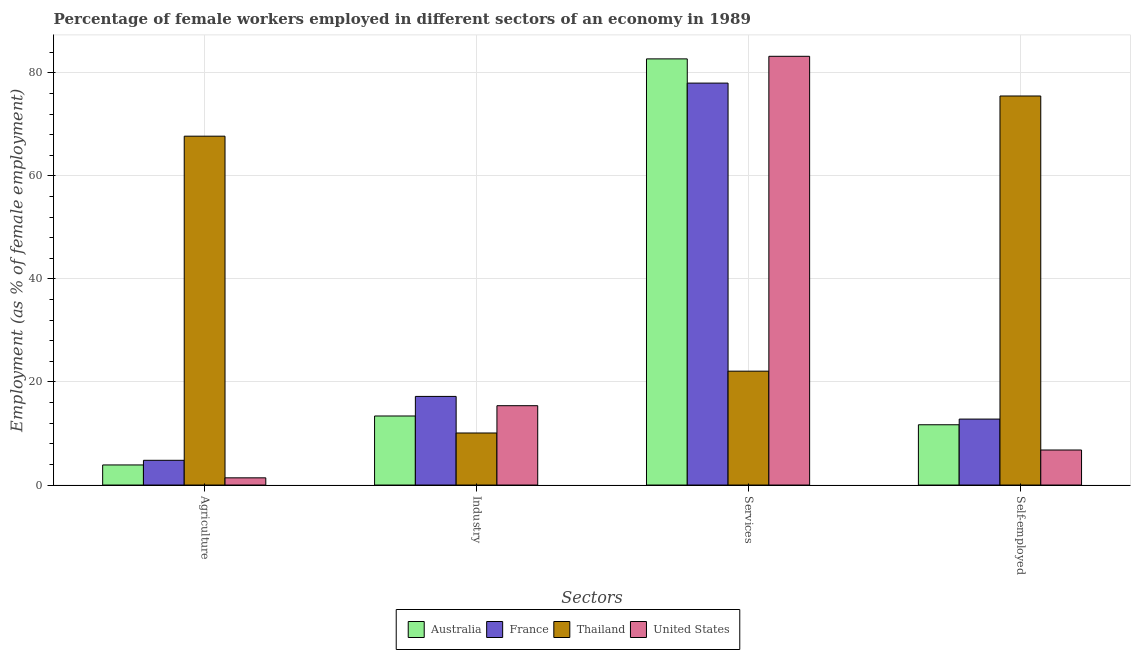How many groups of bars are there?
Provide a short and direct response. 4. How many bars are there on the 2nd tick from the left?
Your answer should be compact. 4. What is the label of the 1st group of bars from the left?
Make the answer very short. Agriculture. What is the percentage of female workers in services in Thailand?
Your answer should be compact. 22.1. Across all countries, what is the maximum percentage of self employed female workers?
Your response must be concise. 75.5. Across all countries, what is the minimum percentage of female workers in agriculture?
Give a very brief answer. 1.4. In which country was the percentage of female workers in agriculture maximum?
Ensure brevity in your answer.  Thailand. In which country was the percentage of female workers in services minimum?
Provide a short and direct response. Thailand. What is the total percentage of female workers in agriculture in the graph?
Provide a short and direct response. 77.8. What is the difference between the percentage of female workers in services in Thailand and that in United States?
Provide a short and direct response. -61.1. What is the difference between the percentage of female workers in services in France and the percentage of self employed female workers in Thailand?
Your response must be concise. 2.5. What is the average percentage of female workers in agriculture per country?
Keep it short and to the point. 19.45. What is the difference between the percentage of self employed female workers and percentage of female workers in services in United States?
Your response must be concise. -76.4. In how many countries, is the percentage of self employed female workers greater than 12 %?
Offer a terse response. 2. What is the ratio of the percentage of female workers in agriculture in France to that in Thailand?
Give a very brief answer. 0.07. Is the difference between the percentage of female workers in agriculture in United States and Thailand greater than the difference between the percentage of female workers in services in United States and Thailand?
Make the answer very short. No. What is the difference between the highest and the second highest percentage of female workers in services?
Your answer should be very brief. 0.5. What is the difference between the highest and the lowest percentage of female workers in industry?
Offer a very short reply. 7.1. In how many countries, is the percentage of female workers in industry greater than the average percentage of female workers in industry taken over all countries?
Offer a very short reply. 2. What does the 3rd bar from the right in Agriculture represents?
Offer a terse response. France. How many bars are there?
Provide a short and direct response. 16. Are the values on the major ticks of Y-axis written in scientific E-notation?
Your answer should be compact. No. Does the graph contain any zero values?
Provide a short and direct response. No. Does the graph contain grids?
Provide a short and direct response. Yes. Where does the legend appear in the graph?
Ensure brevity in your answer.  Bottom center. What is the title of the graph?
Give a very brief answer. Percentage of female workers employed in different sectors of an economy in 1989. What is the label or title of the X-axis?
Offer a terse response. Sectors. What is the label or title of the Y-axis?
Offer a terse response. Employment (as % of female employment). What is the Employment (as % of female employment) of Australia in Agriculture?
Provide a succinct answer. 3.9. What is the Employment (as % of female employment) of France in Agriculture?
Your response must be concise. 4.8. What is the Employment (as % of female employment) of Thailand in Agriculture?
Your response must be concise. 67.7. What is the Employment (as % of female employment) in United States in Agriculture?
Provide a succinct answer. 1.4. What is the Employment (as % of female employment) of Australia in Industry?
Provide a short and direct response. 13.4. What is the Employment (as % of female employment) in France in Industry?
Your answer should be compact. 17.2. What is the Employment (as % of female employment) in Thailand in Industry?
Your response must be concise. 10.1. What is the Employment (as % of female employment) in United States in Industry?
Make the answer very short. 15.4. What is the Employment (as % of female employment) in Australia in Services?
Ensure brevity in your answer.  82.7. What is the Employment (as % of female employment) of France in Services?
Offer a terse response. 78. What is the Employment (as % of female employment) in Thailand in Services?
Provide a succinct answer. 22.1. What is the Employment (as % of female employment) in United States in Services?
Provide a short and direct response. 83.2. What is the Employment (as % of female employment) in Australia in Self-employed?
Offer a terse response. 11.7. What is the Employment (as % of female employment) in France in Self-employed?
Your answer should be compact. 12.8. What is the Employment (as % of female employment) of Thailand in Self-employed?
Keep it short and to the point. 75.5. What is the Employment (as % of female employment) in United States in Self-employed?
Provide a short and direct response. 6.8. Across all Sectors, what is the maximum Employment (as % of female employment) of Australia?
Offer a terse response. 82.7. Across all Sectors, what is the maximum Employment (as % of female employment) in France?
Your answer should be very brief. 78. Across all Sectors, what is the maximum Employment (as % of female employment) of Thailand?
Offer a terse response. 75.5. Across all Sectors, what is the maximum Employment (as % of female employment) in United States?
Make the answer very short. 83.2. Across all Sectors, what is the minimum Employment (as % of female employment) of Australia?
Offer a terse response. 3.9. Across all Sectors, what is the minimum Employment (as % of female employment) of France?
Your response must be concise. 4.8. Across all Sectors, what is the minimum Employment (as % of female employment) in Thailand?
Keep it short and to the point. 10.1. Across all Sectors, what is the minimum Employment (as % of female employment) of United States?
Your answer should be very brief. 1.4. What is the total Employment (as % of female employment) in Australia in the graph?
Offer a terse response. 111.7. What is the total Employment (as % of female employment) in France in the graph?
Your response must be concise. 112.8. What is the total Employment (as % of female employment) in Thailand in the graph?
Offer a terse response. 175.4. What is the total Employment (as % of female employment) in United States in the graph?
Your answer should be compact. 106.8. What is the difference between the Employment (as % of female employment) of Australia in Agriculture and that in Industry?
Offer a very short reply. -9.5. What is the difference between the Employment (as % of female employment) in Thailand in Agriculture and that in Industry?
Give a very brief answer. 57.6. What is the difference between the Employment (as % of female employment) in United States in Agriculture and that in Industry?
Provide a short and direct response. -14. What is the difference between the Employment (as % of female employment) of Australia in Agriculture and that in Services?
Make the answer very short. -78.8. What is the difference between the Employment (as % of female employment) in France in Agriculture and that in Services?
Offer a terse response. -73.2. What is the difference between the Employment (as % of female employment) of Thailand in Agriculture and that in Services?
Give a very brief answer. 45.6. What is the difference between the Employment (as % of female employment) in United States in Agriculture and that in Services?
Make the answer very short. -81.8. What is the difference between the Employment (as % of female employment) of Australia in Agriculture and that in Self-employed?
Ensure brevity in your answer.  -7.8. What is the difference between the Employment (as % of female employment) in France in Agriculture and that in Self-employed?
Provide a succinct answer. -8. What is the difference between the Employment (as % of female employment) in Thailand in Agriculture and that in Self-employed?
Offer a terse response. -7.8. What is the difference between the Employment (as % of female employment) of United States in Agriculture and that in Self-employed?
Your answer should be very brief. -5.4. What is the difference between the Employment (as % of female employment) of Australia in Industry and that in Services?
Your answer should be very brief. -69.3. What is the difference between the Employment (as % of female employment) of France in Industry and that in Services?
Offer a very short reply. -60.8. What is the difference between the Employment (as % of female employment) of Thailand in Industry and that in Services?
Your answer should be very brief. -12. What is the difference between the Employment (as % of female employment) in United States in Industry and that in Services?
Provide a succinct answer. -67.8. What is the difference between the Employment (as % of female employment) of France in Industry and that in Self-employed?
Provide a succinct answer. 4.4. What is the difference between the Employment (as % of female employment) in Thailand in Industry and that in Self-employed?
Provide a succinct answer. -65.4. What is the difference between the Employment (as % of female employment) of Australia in Services and that in Self-employed?
Offer a very short reply. 71. What is the difference between the Employment (as % of female employment) in France in Services and that in Self-employed?
Your answer should be compact. 65.2. What is the difference between the Employment (as % of female employment) in Thailand in Services and that in Self-employed?
Make the answer very short. -53.4. What is the difference between the Employment (as % of female employment) in United States in Services and that in Self-employed?
Your answer should be compact. 76.4. What is the difference between the Employment (as % of female employment) in France in Agriculture and the Employment (as % of female employment) in Thailand in Industry?
Your answer should be very brief. -5.3. What is the difference between the Employment (as % of female employment) of France in Agriculture and the Employment (as % of female employment) of United States in Industry?
Your answer should be compact. -10.6. What is the difference between the Employment (as % of female employment) in Thailand in Agriculture and the Employment (as % of female employment) in United States in Industry?
Ensure brevity in your answer.  52.3. What is the difference between the Employment (as % of female employment) of Australia in Agriculture and the Employment (as % of female employment) of France in Services?
Make the answer very short. -74.1. What is the difference between the Employment (as % of female employment) of Australia in Agriculture and the Employment (as % of female employment) of Thailand in Services?
Your answer should be very brief. -18.2. What is the difference between the Employment (as % of female employment) of Australia in Agriculture and the Employment (as % of female employment) of United States in Services?
Offer a terse response. -79.3. What is the difference between the Employment (as % of female employment) in France in Agriculture and the Employment (as % of female employment) in Thailand in Services?
Ensure brevity in your answer.  -17.3. What is the difference between the Employment (as % of female employment) in France in Agriculture and the Employment (as % of female employment) in United States in Services?
Provide a succinct answer. -78.4. What is the difference between the Employment (as % of female employment) of Thailand in Agriculture and the Employment (as % of female employment) of United States in Services?
Ensure brevity in your answer.  -15.5. What is the difference between the Employment (as % of female employment) of Australia in Agriculture and the Employment (as % of female employment) of France in Self-employed?
Your answer should be very brief. -8.9. What is the difference between the Employment (as % of female employment) in Australia in Agriculture and the Employment (as % of female employment) in Thailand in Self-employed?
Make the answer very short. -71.6. What is the difference between the Employment (as % of female employment) in Australia in Agriculture and the Employment (as % of female employment) in United States in Self-employed?
Give a very brief answer. -2.9. What is the difference between the Employment (as % of female employment) in France in Agriculture and the Employment (as % of female employment) in Thailand in Self-employed?
Ensure brevity in your answer.  -70.7. What is the difference between the Employment (as % of female employment) of Thailand in Agriculture and the Employment (as % of female employment) of United States in Self-employed?
Provide a short and direct response. 60.9. What is the difference between the Employment (as % of female employment) in Australia in Industry and the Employment (as % of female employment) in France in Services?
Ensure brevity in your answer.  -64.6. What is the difference between the Employment (as % of female employment) in Australia in Industry and the Employment (as % of female employment) in Thailand in Services?
Your answer should be compact. -8.7. What is the difference between the Employment (as % of female employment) in Australia in Industry and the Employment (as % of female employment) in United States in Services?
Your answer should be compact. -69.8. What is the difference between the Employment (as % of female employment) in France in Industry and the Employment (as % of female employment) in Thailand in Services?
Give a very brief answer. -4.9. What is the difference between the Employment (as % of female employment) in France in Industry and the Employment (as % of female employment) in United States in Services?
Ensure brevity in your answer.  -66. What is the difference between the Employment (as % of female employment) in Thailand in Industry and the Employment (as % of female employment) in United States in Services?
Make the answer very short. -73.1. What is the difference between the Employment (as % of female employment) in Australia in Industry and the Employment (as % of female employment) in Thailand in Self-employed?
Give a very brief answer. -62.1. What is the difference between the Employment (as % of female employment) of Australia in Industry and the Employment (as % of female employment) of United States in Self-employed?
Give a very brief answer. 6.6. What is the difference between the Employment (as % of female employment) of France in Industry and the Employment (as % of female employment) of Thailand in Self-employed?
Make the answer very short. -58.3. What is the difference between the Employment (as % of female employment) in Thailand in Industry and the Employment (as % of female employment) in United States in Self-employed?
Make the answer very short. 3.3. What is the difference between the Employment (as % of female employment) of Australia in Services and the Employment (as % of female employment) of France in Self-employed?
Ensure brevity in your answer.  69.9. What is the difference between the Employment (as % of female employment) of Australia in Services and the Employment (as % of female employment) of United States in Self-employed?
Make the answer very short. 75.9. What is the difference between the Employment (as % of female employment) in France in Services and the Employment (as % of female employment) in Thailand in Self-employed?
Your answer should be very brief. 2.5. What is the difference between the Employment (as % of female employment) in France in Services and the Employment (as % of female employment) in United States in Self-employed?
Make the answer very short. 71.2. What is the average Employment (as % of female employment) of Australia per Sectors?
Offer a very short reply. 27.93. What is the average Employment (as % of female employment) in France per Sectors?
Offer a terse response. 28.2. What is the average Employment (as % of female employment) in Thailand per Sectors?
Offer a very short reply. 43.85. What is the average Employment (as % of female employment) of United States per Sectors?
Offer a terse response. 26.7. What is the difference between the Employment (as % of female employment) in Australia and Employment (as % of female employment) in France in Agriculture?
Keep it short and to the point. -0.9. What is the difference between the Employment (as % of female employment) of Australia and Employment (as % of female employment) of Thailand in Agriculture?
Your response must be concise. -63.8. What is the difference between the Employment (as % of female employment) of Australia and Employment (as % of female employment) of United States in Agriculture?
Give a very brief answer. 2.5. What is the difference between the Employment (as % of female employment) in France and Employment (as % of female employment) in Thailand in Agriculture?
Your answer should be compact. -62.9. What is the difference between the Employment (as % of female employment) of Thailand and Employment (as % of female employment) of United States in Agriculture?
Offer a very short reply. 66.3. What is the difference between the Employment (as % of female employment) in Australia and Employment (as % of female employment) in Thailand in Industry?
Give a very brief answer. 3.3. What is the difference between the Employment (as % of female employment) in Australia and Employment (as % of female employment) in United States in Industry?
Provide a succinct answer. -2. What is the difference between the Employment (as % of female employment) in France and Employment (as % of female employment) in United States in Industry?
Your answer should be very brief. 1.8. What is the difference between the Employment (as % of female employment) of Australia and Employment (as % of female employment) of Thailand in Services?
Provide a succinct answer. 60.6. What is the difference between the Employment (as % of female employment) in Australia and Employment (as % of female employment) in United States in Services?
Your answer should be compact. -0.5. What is the difference between the Employment (as % of female employment) in France and Employment (as % of female employment) in Thailand in Services?
Ensure brevity in your answer.  55.9. What is the difference between the Employment (as % of female employment) in Thailand and Employment (as % of female employment) in United States in Services?
Make the answer very short. -61.1. What is the difference between the Employment (as % of female employment) of Australia and Employment (as % of female employment) of Thailand in Self-employed?
Offer a terse response. -63.8. What is the difference between the Employment (as % of female employment) in France and Employment (as % of female employment) in Thailand in Self-employed?
Provide a succinct answer. -62.7. What is the difference between the Employment (as % of female employment) in Thailand and Employment (as % of female employment) in United States in Self-employed?
Ensure brevity in your answer.  68.7. What is the ratio of the Employment (as % of female employment) of Australia in Agriculture to that in Industry?
Make the answer very short. 0.29. What is the ratio of the Employment (as % of female employment) of France in Agriculture to that in Industry?
Provide a short and direct response. 0.28. What is the ratio of the Employment (as % of female employment) of Thailand in Agriculture to that in Industry?
Your answer should be very brief. 6.7. What is the ratio of the Employment (as % of female employment) in United States in Agriculture to that in Industry?
Your answer should be compact. 0.09. What is the ratio of the Employment (as % of female employment) in Australia in Agriculture to that in Services?
Make the answer very short. 0.05. What is the ratio of the Employment (as % of female employment) of France in Agriculture to that in Services?
Your response must be concise. 0.06. What is the ratio of the Employment (as % of female employment) of Thailand in Agriculture to that in Services?
Give a very brief answer. 3.06. What is the ratio of the Employment (as % of female employment) in United States in Agriculture to that in Services?
Give a very brief answer. 0.02. What is the ratio of the Employment (as % of female employment) in Thailand in Agriculture to that in Self-employed?
Give a very brief answer. 0.9. What is the ratio of the Employment (as % of female employment) in United States in Agriculture to that in Self-employed?
Keep it short and to the point. 0.21. What is the ratio of the Employment (as % of female employment) in Australia in Industry to that in Services?
Offer a very short reply. 0.16. What is the ratio of the Employment (as % of female employment) in France in Industry to that in Services?
Give a very brief answer. 0.22. What is the ratio of the Employment (as % of female employment) of Thailand in Industry to that in Services?
Your answer should be compact. 0.46. What is the ratio of the Employment (as % of female employment) in United States in Industry to that in Services?
Provide a short and direct response. 0.19. What is the ratio of the Employment (as % of female employment) of Australia in Industry to that in Self-employed?
Provide a short and direct response. 1.15. What is the ratio of the Employment (as % of female employment) in France in Industry to that in Self-employed?
Offer a very short reply. 1.34. What is the ratio of the Employment (as % of female employment) of Thailand in Industry to that in Self-employed?
Ensure brevity in your answer.  0.13. What is the ratio of the Employment (as % of female employment) of United States in Industry to that in Self-employed?
Ensure brevity in your answer.  2.26. What is the ratio of the Employment (as % of female employment) of Australia in Services to that in Self-employed?
Your answer should be compact. 7.07. What is the ratio of the Employment (as % of female employment) of France in Services to that in Self-employed?
Provide a succinct answer. 6.09. What is the ratio of the Employment (as % of female employment) of Thailand in Services to that in Self-employed?
Your answer should be compact. 0.29. What is the ratio of the Employment (as % of female employment) in United States in Services to that in Self-employed?
Make the answer very short. 12.24. What is the difference between the highest and the second highest Employment (as % of female employment) of Australia?
Offer a very short reply. 69.3. What is the difference between the highest and the second highest Employment (as % of female employment) in France?
Provide a succinct answer. 60.8. What is the difference between the highest and the second highest Employment (as % of female employment) in United States?
Keep it short and to the point. 67.8. What is the difference between the highest and the lowest Employment (as % of female employment) of Australia?
Your answer should be very brief. 78.8. What is the difference between the highest and the lowest Employment (as % of female employment) in France?
Give a very brief answer. 73.2. What is the difference between the highest and the lowest Employment (as % of female employment) in Thailand?
Your answer should be compact. 65.4. What is the difference between the highest and the lowest Employment (as % of female employment) of United States?
Keep it short and to the point. 81.8. 